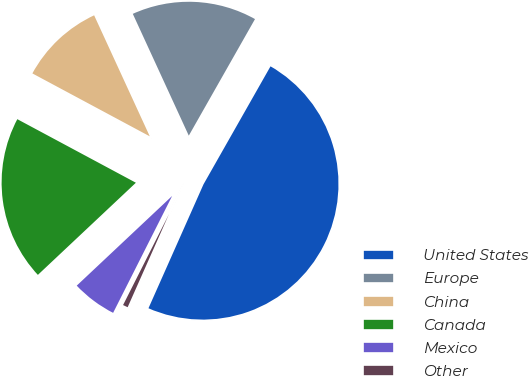Convert chart to OTSL. <chart><loc_0><loc_0><loc_500><loc_500><pie_chart><fcel>United States<fcel>Europe<fcel>China<fcel>Canada<fcel>Mexico<fcel>Other<nl><fcel>48.43%<fcel>15.08%<fcel>10.31%<fcel>19.84%<fcel>5.55%<fcel>0.79%<nl></chart> 